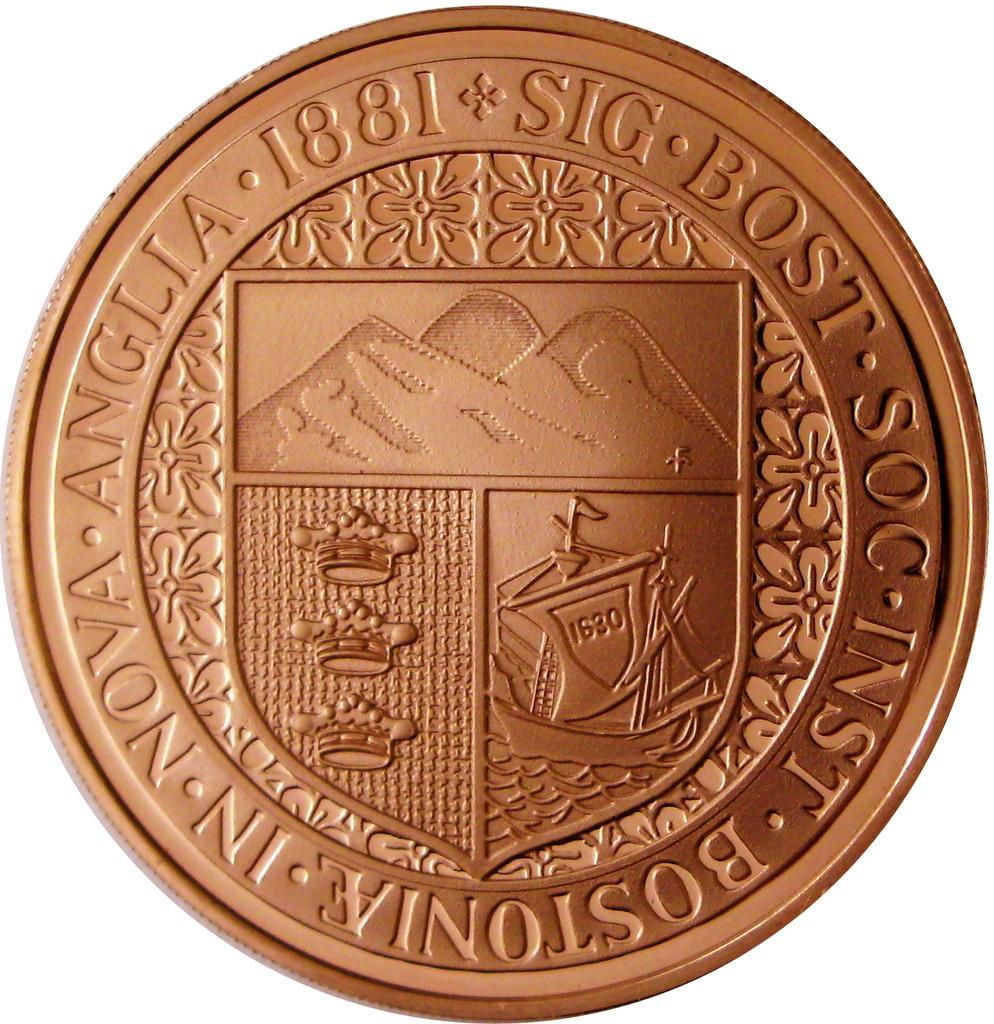<image>
Render a clear and concise summary of the photo. A foreign coin has the year 1881 printed on it. 